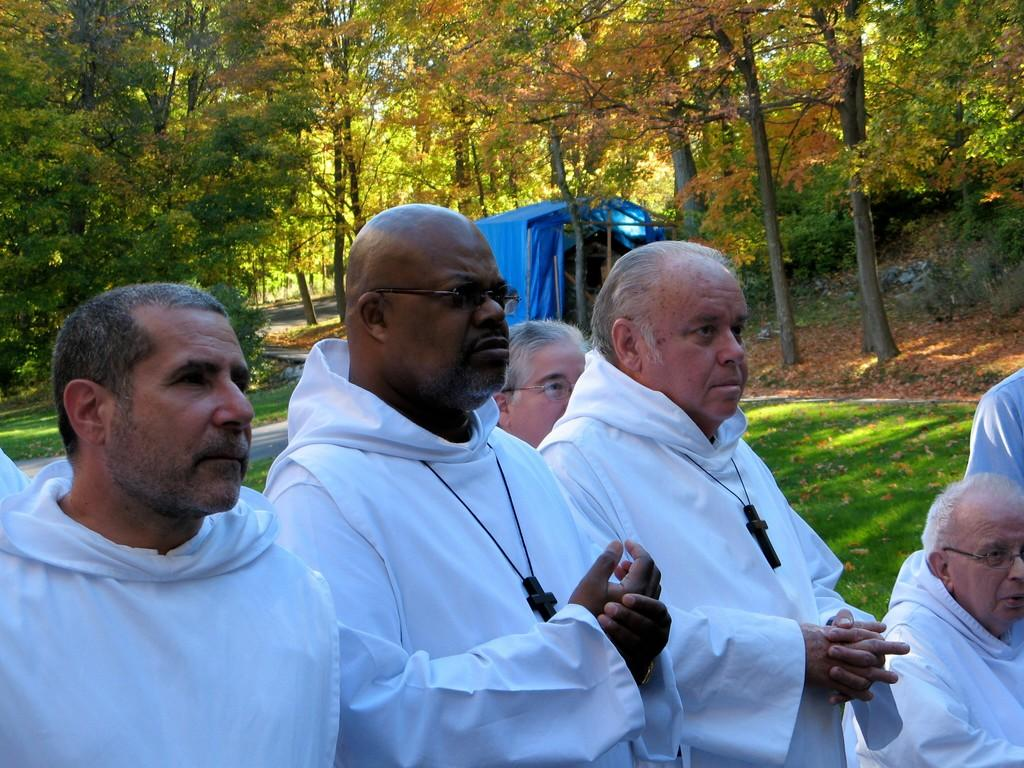Who is present in the image? There are old men in the image. What are the old men wearing? The old men are wearing white hoodies and necklaces. What are the old men doing in the image? The old men are standing. What can be seen in the background of the image? There are trees and a tent on the grassland in the background of the image. Where is the drain located in the image? There is no drain present in the image. What type of nut is being cracked by the old men in the image? There is no nut-cracking activity depicted in the image; the old men are simply standing. 